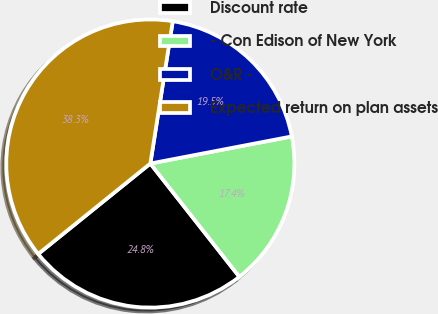<chart> <loc_0><loc_0><loc_500><loc_500><pie_chart><fcel>Discount rate<fcel>- Con Edison of New York<fcel>O&R -<fcel>Expected return on plan assets<nl><fcel>24.8%<fcel>17.41%<fcel>19.5%<fcel>38.29%<nl></chart> 